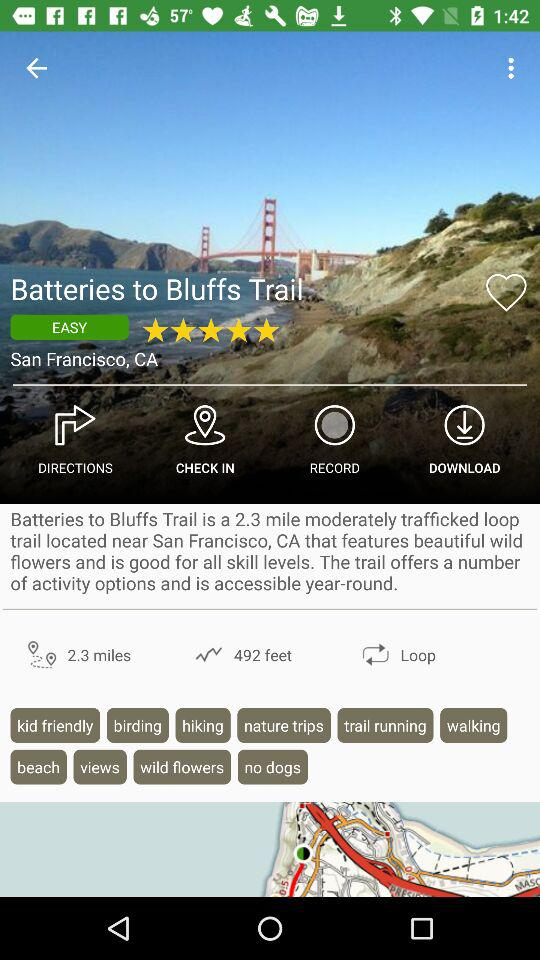How many trails in total are available? There are 50,000+ trails available. 